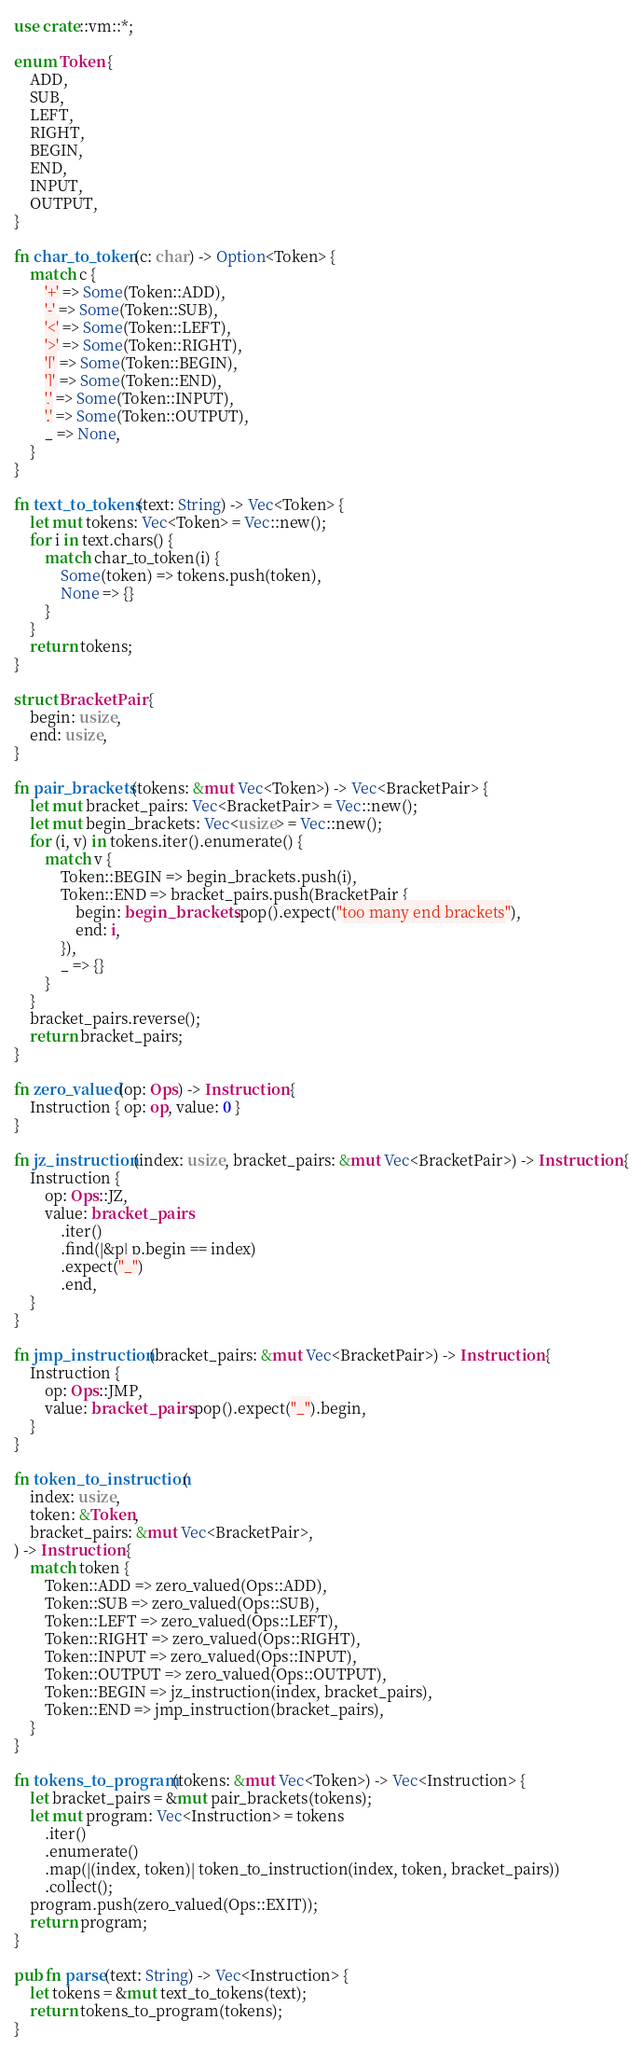Convert code to text. <code><loc_0><loc_0><loc_500><loc_500><_Rust_>use crate::vm::*;

enum Token {
    ADD,
    SUB,
    LEFT,
    RIGHT,
    BEGIN,
    END,
    INPUT,
    OUTPUT,
}

fn char_to_token(c: char) -> Option<Token> {
    match c {
        '+' => Some(Token::ADD),
        '-' => Some(Token::SUB),
        '<' => Some(Token::LEFT),
        '>' => Some(Token::RIGHT),
        '[' => Some(Token::BEGIN),
        ']' => Some(Token::END),
        ',' => Some(Token::INPUT),
        '.' => Some(Token::OUTPUT),
        _ => None,
    }
}

fn text_to_tokens(text: String) -> Vec<Token> {
    let mut tokens: Vec<Token> = Vec::new();
    for i in text.chars() {
        match char_to_token(i) {
            Some(token) => tokens.push(token),
            None => {}
        }
    }
    return tokens;
}

struct BracketPair {
    begin: usize,
    end: usize,
}

fn pair_brackets(tokens: &mut Vec<Token>) -> Vec<BracketPair> {
    let mut bracket_pairs: Vec<BracketPair> = Vec::new();
    let mut begin_brackets: Vec<usize> = Vec::new();
    for (i, v) in tokens.iter().enumerate() {
        match v {
            Token::BEGIN => begin_brackets.push(i),
            Token::END => bracket_pairs.push(BracketPair {
                begin: begin_brackets.pop().expect("too many end brackets"),
                end: i,
            }),
            _ => {}
        }
    }
    bracket_pairs.reverse();
    return bracket_pairs;
}

fn zero_valued(op: Ops) -> Instruction {
    Instruction { op: op, value: 0 }
}

fn jz_instruction(index: usize, bracket_pairs: &mut Vec<BracketPair>) -> Instruction {
    Instruction {
        op: Ops::JZ,
        value: bracket_pairs
            .iter()
            .find(|&p| p.begin == index)
            .expect("_")
            .end,
    }
}

fn jmp_instruction(bracket_pairs: &mut Vec<BracketPair>) -> Instruction {
    Instruction {
        op: Ops::JMP,
        value: bracket_pairs.pop().expect("_").begin,
    }
}

fn token_to_instruction(
    index: usize,
    token: &Token,
    bracket_pairs: &mut Vec<BracketPair>,
) -> Instruction {
    match token {
        Token::ADD => zero_valued(Ops::ADD),
        Token::SUB => zero_valued(Ops::SUB),
        Token::LEFT => zero_valued(Ops::LEFT),
        Token::RIGHT => zero_valued(Ops::RIGHT),
        Token::INPUT => zero_valued(Ops::INPUT),
        Token::OUTPUT => zero_valued(Ops::OUTPUT),
        Token::BEGIN => jz_instruction(index, bracket_pairs),
        Token::END => jmp_instruction(bracket_pairs),
    }
}

fn tokens_to_program(tokens: &mut Vec<Token>) -> Vec<Instruction> {
    let bracket_pairs = &mut pair_brackets(tokens);
    let mut program: Vec<Instruction> = tokens
        .iter()
        .enumerate()
        .map(|(index, token)| token_to_instruction(index, token, bracket_pairs))
        .collect();
    program.push(zero_valued(Ops::EXIT));
    return program;
}

pub fn parse(text: String) -> Vec<Instruction> {
    let tokens = &mut text_to_tokens(text);
    return tokens_to_program(tokens);
}
</code> 